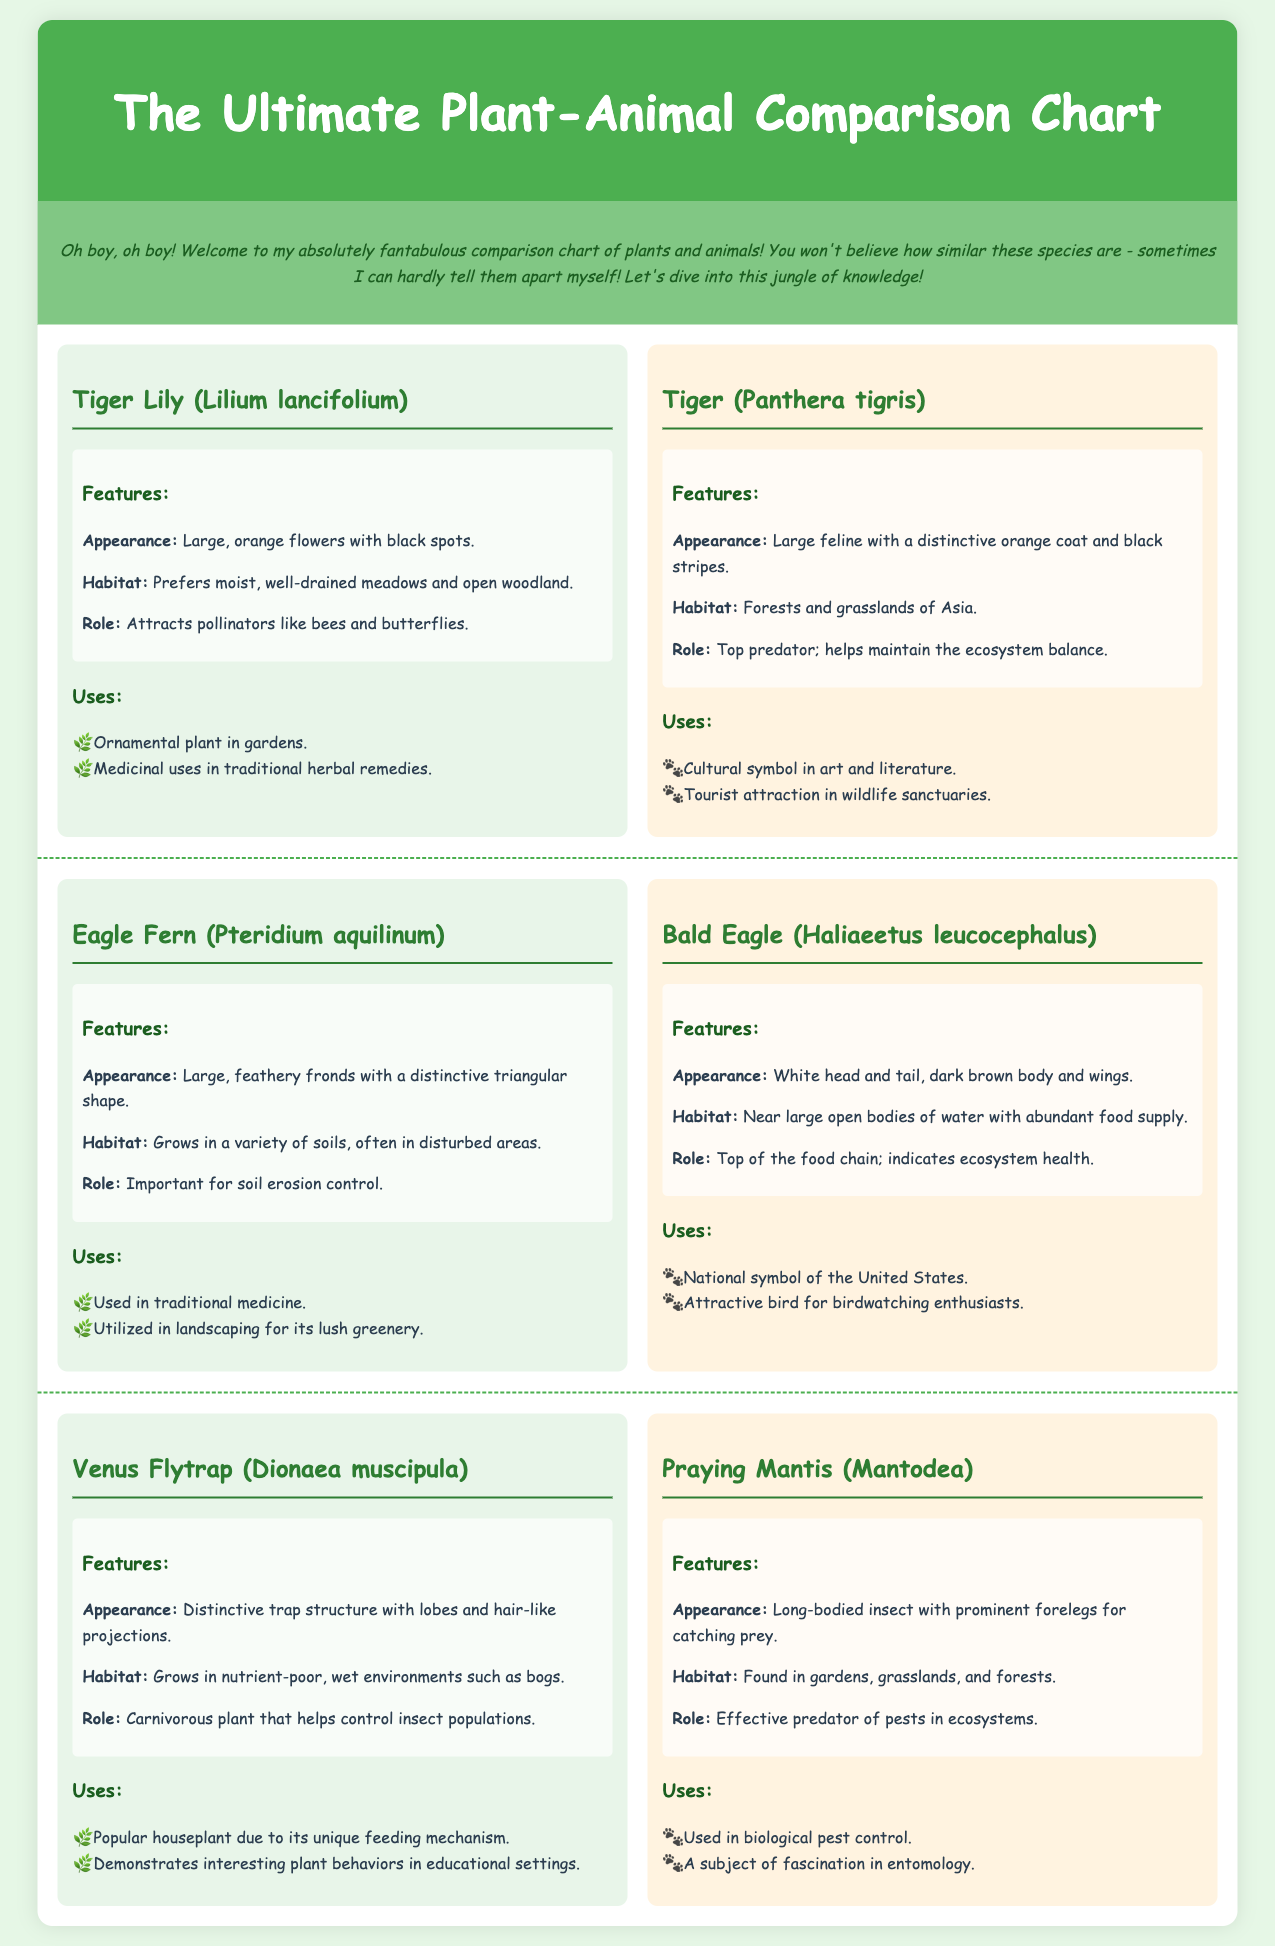What is the plant species compared to the Tiger? The document contains a comparison of the Tiger Lily with the Tiger.
Answer: Tiger Lily (Lilium lancifolium) What is the habitat of the Bald Eagle? The habitat section of the Bald Eagle entry states that it is near large open bodies of water with abundant food supply.
Answer: Near large open bodies of water What role does the Venus Flytrap play in the ecosystem? The document states that the Venus Flytrap helps control insect populations.
Answer: Helps control insect populations What is the main feature of the Tiger Lily? The main feature described is its large, orange flowers with black spots.
Answer: Large, orange flowers with black spots Which animal is depicted as a top predator? The comparison entry clearly states that the Tiger is a top predator; it helps maintain the ecosystem balance.
Answer: Tiger What uses are listed for the Praying Mantis? The uses section of the Praying Mantis indicates it is used in biological pest control.
Answer: Biological pest control What is the appearance of the Eagle Fern? The comparison features of the Eagle Fern describe it as having large, feathery fronds with a distinctive triangular shape.
Answer: Large, feathery fronds with a distinctive triangular shape How many species are compared in this chart? The document compares three pairs of species throughout its content.
Answer: Three pairs What color is the background of the document? The style section indicates that the background color is a light green shade #e6f7e6.
Answer: Light green 